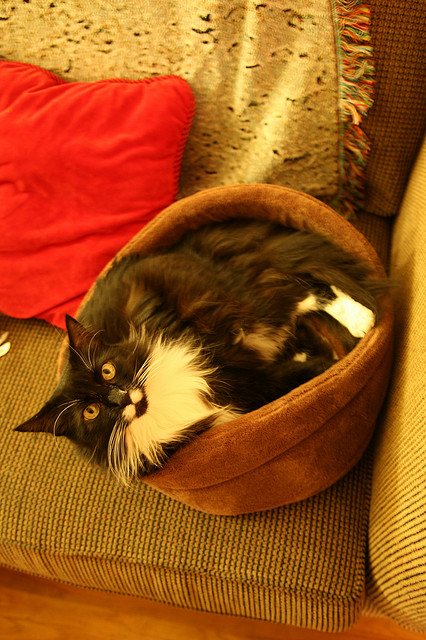<image>What color is the 'moustache'? I am not sure. The moustache is not visible in the image. What color is the 'moustache'? The 'moustache' is white. 